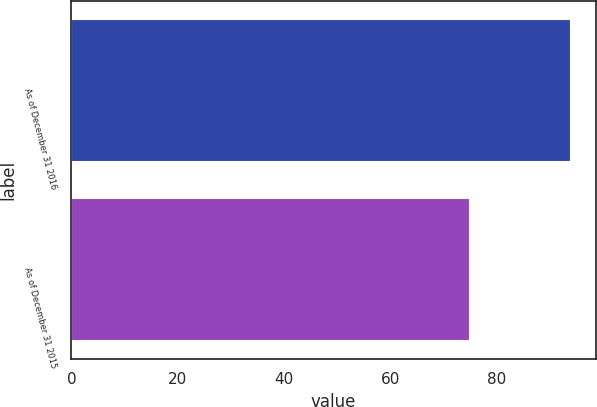<chart> <loc_0><loc_0><loc_500><loc_500><bar_chart><fcel>As of December 31 2016<fcel>As of December 31 2015<nl><fcel>94<fcel>75<nl></chart> 